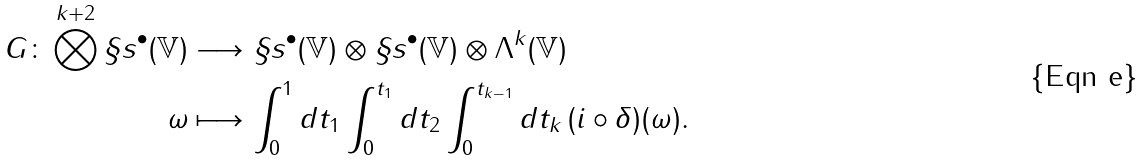Convert formula to latex. <formula><loc_0><loc_0><loc_500><loc_500>G \colon \bigotimes ^ { k + 2 } \S s ^ { \bullet } ( \mathbb { V } ) & \longrightarrow \S s ^ { \bullet } ( \mathbb { V } ) \otimes \S s ^ { \bullet } ( \mathbb { V } ) \otimes \Lambda ^ { k } ( \mathbb { V } ) \\ \omega & \longmapsto \int _ { 0 } ^ { 1 } d t _ { 1 } \int _ { 0 } ^ { t _ { 1 } } d t _ { 2 } \int _ { 0 } ^ { t _ { k - 1 } } d t _ { k } \, ( i \circ \delta ) ( \omega ) .</formula> 